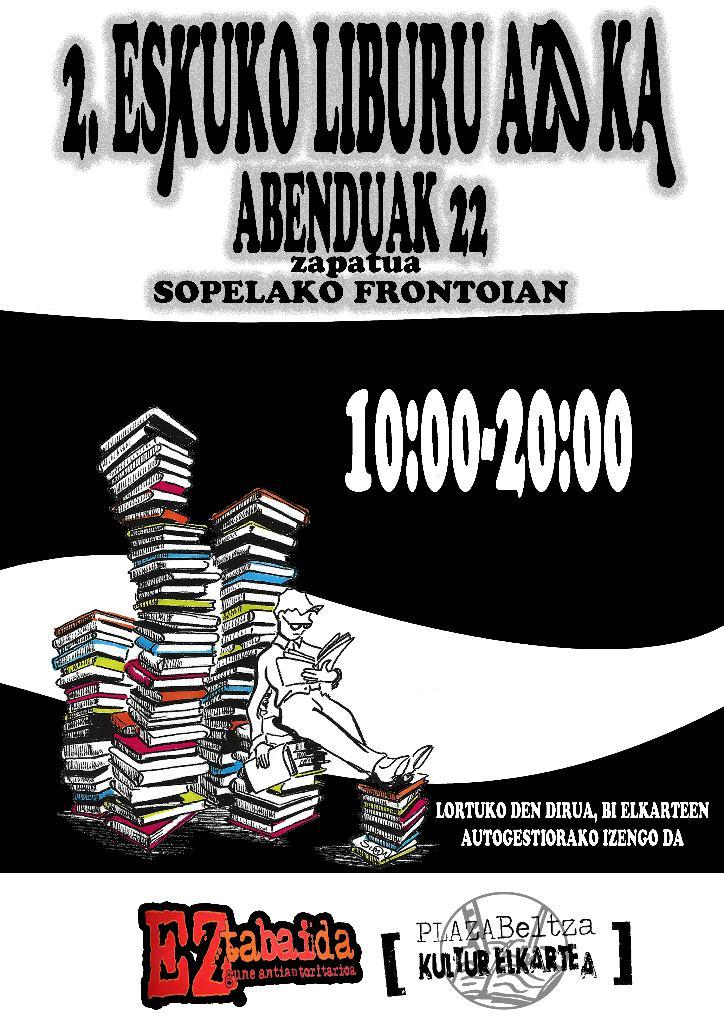<image>
Give a short and clear explanation of the subsequent image. A black and white sign that says Eskuko Liburu Azoka as the title. 